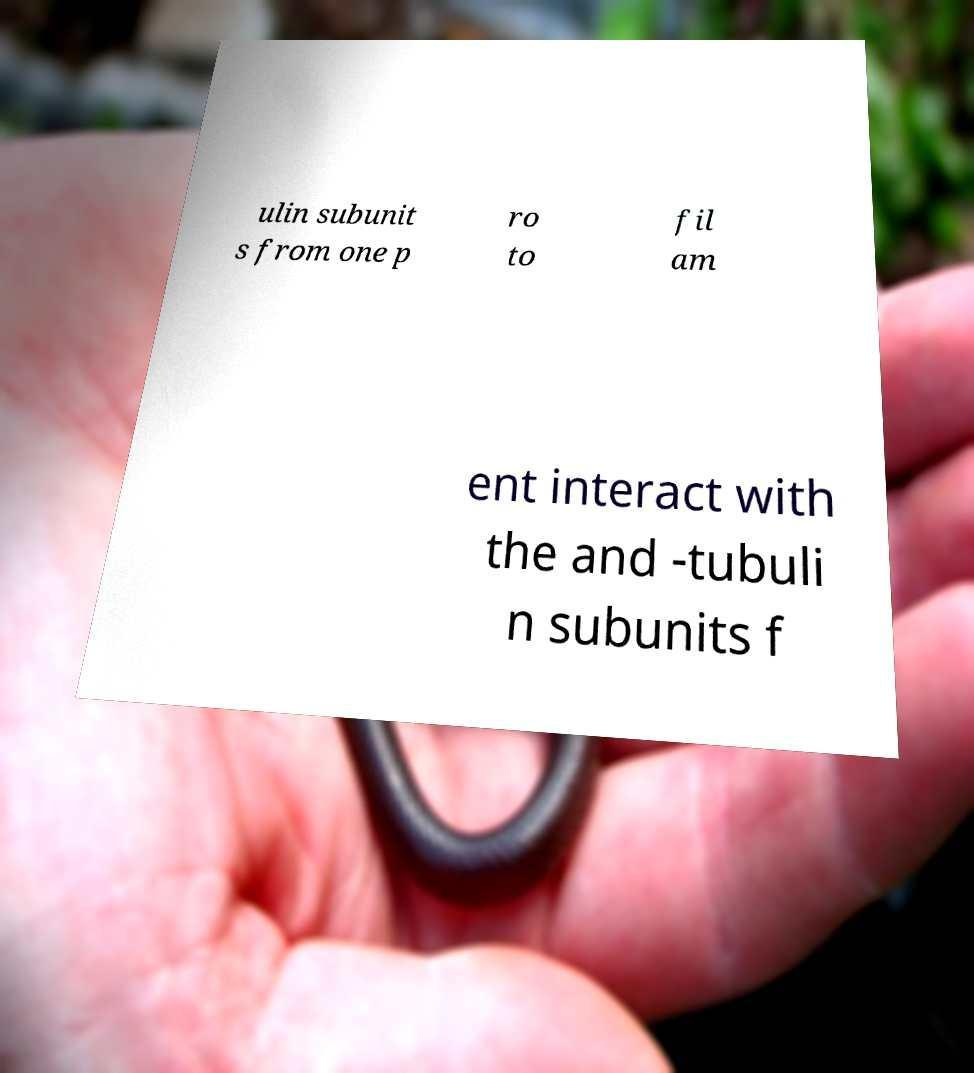Could you assist in decoding the text presented in this image and type it out clearly? ulin subunit s from one p ro to fil am ent interact with the and -tubuli n subunits f 